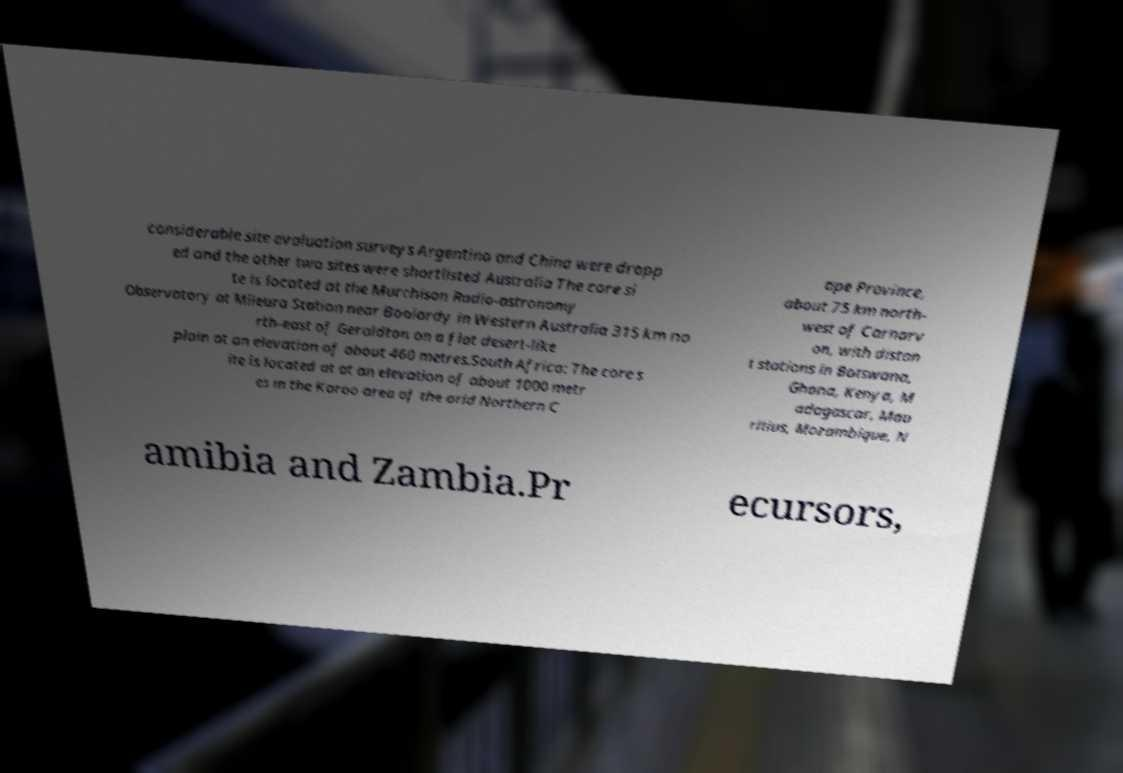Please read and relay the text visible in this image. What does it say? considerable site evaluation surveys Argentina and China were dropp ed and the other two sites were shortlisted Australia The core si te is located at the Murchison Radio-astronomy Observatory at Mileura Station near Boolardy in Western Australia 315 km no rth-east of Geraldton on a flat desert-like plain at an elevation of about 460 metres.South Africa: The core s ite is located at at an elevation of about 1000 metr es in the Karoo area of the arid Northern C ape Province, about 75 km north- west of Carnarv on, with distan t stations in Botswana, Ghana, Kenya, M adagascar, Mau ritius, Mozambique, N amibia and Zambia.Pr ecursors, 